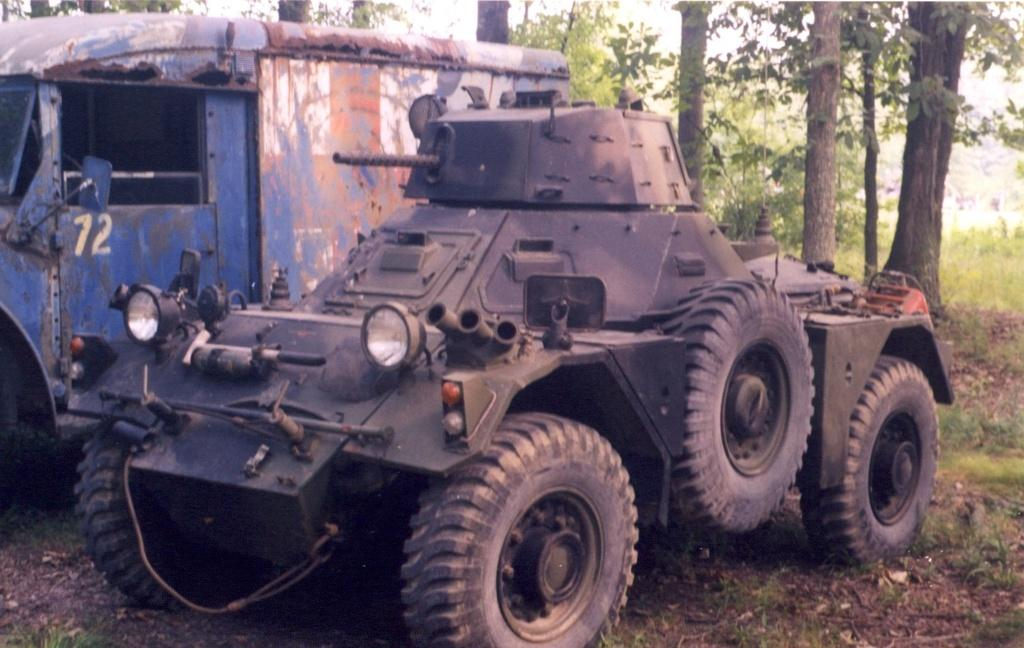What types of objects are on the ground in the image? There are vehicles on the ground in the image. What type of terrain is visible at the bottom of the image? Grass is visible at the bottom of the image. What other natural elements can be seen in the image? There are plants in the image. What can be seen in the distance in the image? There are many trees in the background of the image. How many cats are sitting on the vehicles in the image? There are no cats present in the image; it only features vehicles, grass, plants, and trees. 